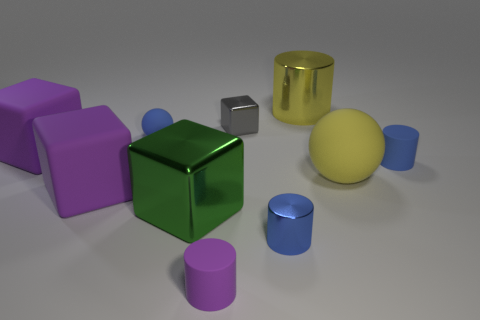Subtract all blue metallic cylinders. How many cylinders are left? 3 Subtract all yellow spheres. How many purple cubes are left? 2 Subtract 1 blocks. How many blocks are left? 3 Subtract all gray cubes. How many cubes are left? 3 Subtract all blocks. How many objects are left? 6 Subtract all cyan cylinders. Subtract all brown balls. How many cylinders are left? 4 Add 4 blue rubber things. How many blue rubber things are left? 6 Add 4 purple blocks. How many purple blocks exist? 6 Subtract 0 red cylinders. How many objects are left? 10 Subtract all large things. Subtract all tiny blue matte objects. How many objects are left? 3 